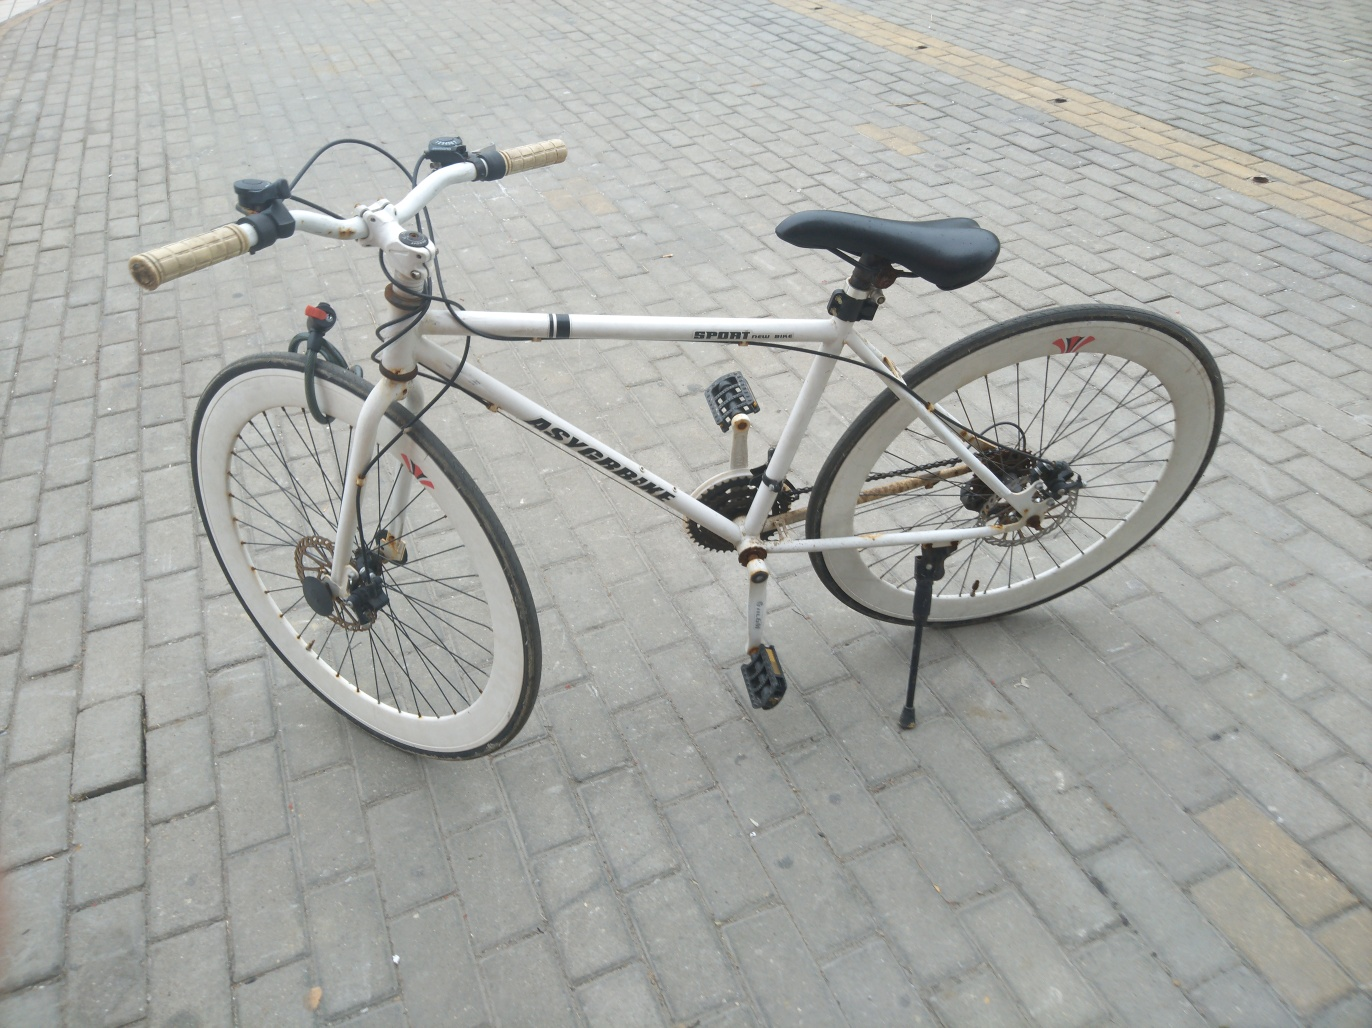Does the image have good lighting?
 Yes 